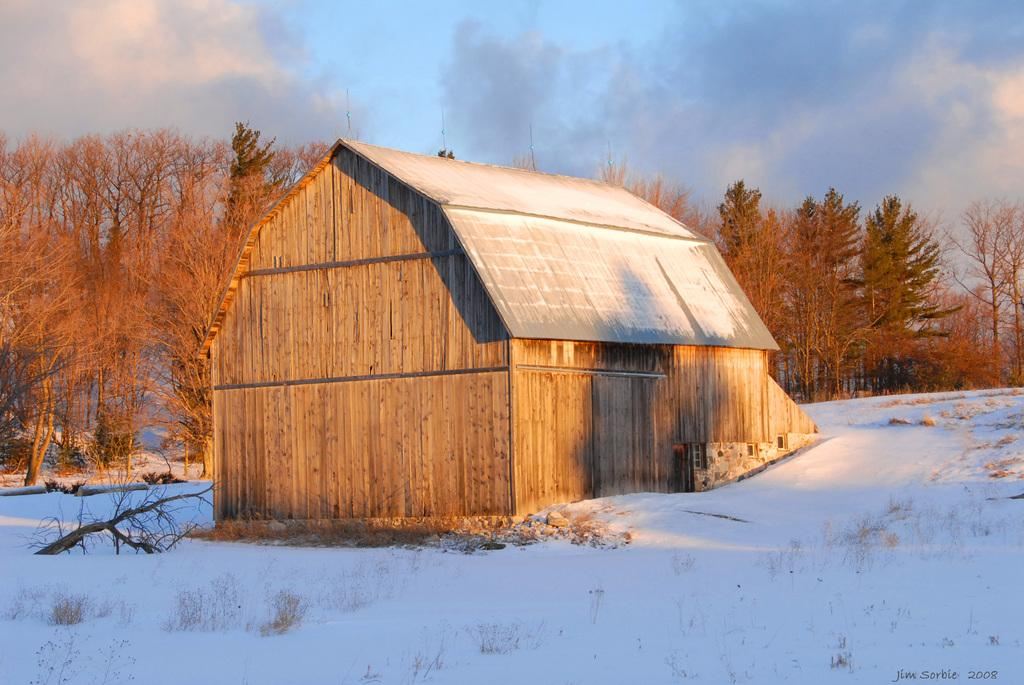What type of house is in the image? There is a wooden house in the image. Where is the wooden house located? The wooden house is on the surface of the snow. What can be seen behind the wooden house? There are trees behind the wooden house. What type of bun is being used to decorate the wooden house in the image? There is no bun present in the image; it features a wooden house on the snow with trees behind it. 